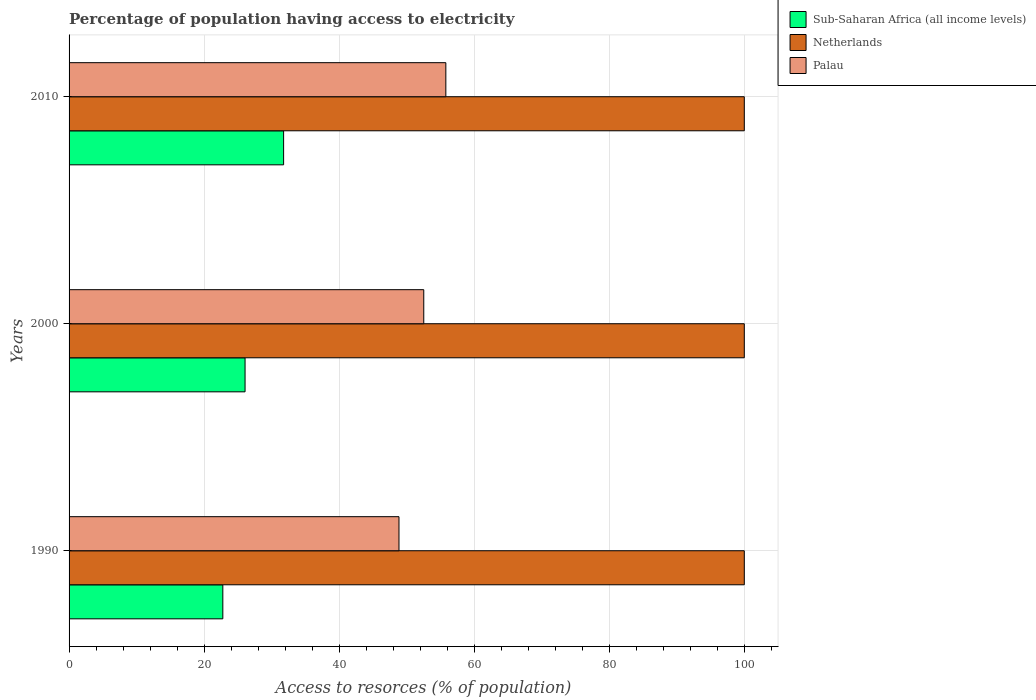How many different coloured bars are there?
Ensure brevity in your answer.  3. How many groups of bars are there?
Provide a short and direct response. 3. Are the number of bars per tick equal to the number of legend labels?
Offer a very short reply. Yes. In how many cases, is the number of bars for a given year not equal to the number of legend labels?
Your response must be concise. 0. What is the percentage of population having access to electricity in Palau in 2000?
Your answer should be compact. 52.53. Across all years, what is the maximum percentage of population having access to electricity in Sub-Saharan Africa (all income levels)?
Your response must be concise. 31.77. Across all years, what is the minimum percentage of population having access to electricity in Netherlands?
Your answer should be very brief. 100. In which year was the percentage of population having access to electricity in Netherlands minimum?
Keep it short and to the point. 1990. What is the total percentage of population having access to electricity in Netherlands in the graph?
Offer a terse response. 300. What is the difference between the percentage of population having access to electricity in Palau in 1990 and that in 2010?
Keep it short and to the point. -6.94. What is the difference between the percentage of population having access to electricity in Palau in 1990 and the percentage of population having access to electricity in Sub-Saharan Africa (all income levels) in 2000?
Ensure brevity in your answer.  22.79. What is the average percentage of population having access to electricity in Sub-Saharan Africa (all income levels) per year?
Offer a very short reply. 26.87. In the year 2000, what is the difference between the percentage of population having access to electricity in Palau and percentage of population having access to electricity in Sub-Saharan Africa (all income levels)?
Your response must be concise. 26.47. In how many years, is the percentage of population having access to electricity in Netherlands greater than 24 %?
Ensure brevity in your answer.  3. What is the ratio of the percentage of population having access to electricity in Sub-Saharan Africa (all income levels) in 1990 to that in 2000?
Provide a succinct answer. 0.87. What is the difference between the highest and the lowest percentage of population having access to electricity in Netherlands?
Keep it short and to the point. 0. In how many years, is the percentage of population having access to electricity in Sub-Saharan Africa (all income levels) greater than the average percentage of population having access to electricity in Sub-Saharan Africa (all income levels) taken over all years?
Offer a very short reply. 1. What does the 1st bar from the bottom in 2000 represents?
Offer a very short reply. Sub-Saharan Africa (all income levels). Are all the bars in the graph horizontal?
Keep it short and to the point. Yes. What is the difference between two consecutive major ticks on the X-axis?
Your response must be concise. 20. Does the graph contain any zero values?
Your answer should be very brief. No. How are the legend labels stacked?
Offer a very short reply. Vertical. What is the title of the graph?
Offer a very short reply. Percentage of population having access to electricity. Does "Jamaica" appear as one of the legend labels in the graph?
Ensure brevity in your answer.  No. What is the label or title of the X-axis?
Make the answer very short. Access to resorces (% of population). What is the Access to resorces (% of population) of Sub-Saharan Africa (all income levels) in 1990?
Keep it short and to the point. 22.77. What is the Access to resorces (% of population) in Netherlands in 1990?
Provide a succinct answer. 100. What is the Access to resorces (% of population) in Palau in 1990?
Your response must be concise. 48.86. What is the Access to resorces (% of population) of Sub-Saharan Africa (all income levels) in 2000?
Offer a terse response. 26.06. What is the Access to resorces (% of population) in Netherlands in 2000?
Offer a very short reply. 100. What is the Access to resorces (% of population) of Palau in 2000?
Give a very brief answer. 52.53. What is the Access to resorces (% of population) of Sub-Saharan Africa (all income levels) in 2010?
Ensure brevity in your answer.  31.77. What is the Access to resorces (% of population) in Palau in 2010?
Provide a succinct answer. 55.8. Across all years, what is the maximum Access to resorces (% of population) of Sub-Saharan Africa (all income levels)?
Keep it short and to the point. 31.77. Across all years, what is the maximum Access to resorces (% of population) of Netherlands?
Your response must be concise. 100. Across all years, what is the maximum Access to resorces (% of population) in Palau?
Your response must be concise. 55.8. Across all years, what is the minimum Access to resorces (% of population) in Sub-Saharan Africa (all income levels)?
Your answer should be compact. 22.77. Across all years, what is the minimum Access to resorces (% of population) of Netherlands?
Keep it short and to the point. 100. Across all years, what is the minimum Access to resorces (% of population) in Palau?
Your response must be concise. 48.86. What is the total Access to resorces (% of population) in Sub-Saharan Africa (all income levels) in the graph?
Your response must be concise. 80.61. What is the total Access to resorces (% of population) of Netherlands in the graph?
Keep it short and to the point. 300. What is the total Access to resorces (% of population) in Palau in the graph?
Your answer should be compact. 157.19. What is the difference between the Access to resorces (% of population) in Sub-Saharan Africa (all income levels) in 1990 and that in 2000?
Give a very brief answer. -3.29. What is the difference between the Access to resorces (% of population) in Netherlands in 1990 and that in 2000?
Give a very brief answer. 0. What is the difference between the Access to resorces (% of population) of Palau in 1990 and that in 2000?
Offer a very short reply. -3.67. What is the difference between the Access to resorces (% of population) in Sub-Saharan Africa (all income levels) in 1990 and that in 2010?
Ensure brevity in your answer.  -9. What is the difference between the Access to resorces (% of population) of Palau in 1990 and that in 2010?
Your answer should be very brief. -6.94. What is the difference between the Access to resorces (% of population) of Sub-Saharan Africa (all income levels) in 2000 and that in 2010?
Provide a short and direct response. -5.71. What is the difference between the Access to resorces (% of population) of Palau in 2000 and that in 2010?
Your answer should be very brief. -3.27. What is the difference between the Access to resorces (% of population) in Sub-Saharan Africa (all income levels) in 1990 and the Access to resorces (% of population) in Netherlands in 2000?
Make the answer very short. -77.23. What is the difference between the Access to resorces (% of population) in Sub-Saharan Africa (all income levels) in 1990 and the Access to resorces (% of population) in Palau in 2000?
Your answer should be very brief. -29.76. What is the difference between the Access to resorces (% of population) of Netherlands in 1990 and the Access to resorces (% of population) of Palau in 2000?
Give a very brief answer. 47.47. What is the difference between the Access to resorces (% of population) of Sub-Saharan Africa (all income levels) in 1990 and the Access to resorces (% of population) of Netherlands in 2010?
Offer a very short reply. -77.23. What is the difference between the Access to resorces (% of population) in Sub-Saharan Africa (all income levels) in 1990 and the Access to resorces (% of population) in Palau in 2010?
Offer a very short reply. -33.03. What is the difference between the Access to resorces (% of population) of Netherlands in 1990 and the Access to resorces (% of population) of Palau in 2010?
Your response must be concise. 44.2. What is the difference between the Access to resorces (% of population) in Sub-Saharan Africa (all income levels) in 2000 and the Access to resorces (% of population) in Netherlands in 2010?
Your answer should be compact. -73.94. What is the difference between the Access to resorces (% of population) of Sub-Saharan Africa (all income levels) in 2000 and the Access to resorces (% of population) of Palau in 2010?
Keep it short and to the point. -29.74. What is the difference between the Access to resorces (% of population) in Netherlands in 2000 and the Access to resorces (% of population) in Palau in 2010?
Your answer should be very brief. 44.2. What is the average Access to resorces (% of population) of Sub-Saharan Africa (all income levels) per year?
Your answer should be compact. 26.87. What is the average Access to resorces (% of population) of Palau per year?
Your response must be concise. 52.4. In the year 1990, what is the difference between the Access to resorces (% of population) of Sub-Saharan Africa (all income levels) and Access to resorces (% of population) of Netherlands?
Provide a succinct answer. -77.23. In the year 1990, what is the difference between the Access to resorces (% of population) of Sub-Saharan Africa (all income levels) and Access to resorces (% of population) of Palau?
Offer a terse response. -26.09. In the year 1990, what is the difference between the Access to resorces (% of population) in Netherlands and Access to resorces (% of population) in Palau?
Offer a terse response. 51.14. In the year 2000, what is the difference between the Access to resorces (% of population) of Sub-Saharan Africa (all income levels) and Access to resorces (% of population) of Netherlands?
Your response must be concise. -73.94. In the year 2000, what is the difference between the Access to resorces (% of population) of Sub-Saharan Africa (all income levels) and Access to resorces (% of population) of Palau?
Provide a short and direct response. -26.47. In the year 2000, what is the difference between the Access to resorces (% of population) of Netherlands and Access to resorces (% of population) of Palau?
Provide a succinct answer. 47.47. In the year 2010, what is the difference between the Access to resorces (% of population) of Sub-Saharan Africa (all income levels) and Access to resorces (% of population) of Netherlands?
Provide a succinct answer. -68.23. In the year 2010, what is the difference between the Access to resorces (% of population) in Sub-Saharan Africa (all income levels) and Access to resorces (% of population) in Palau?
Ensure brevity in your answer.  -24.03. In the year 2010, what is the difference between the Access to resorces (% of population) of Netherlands and Access to resorces (% of population) of Palau?
Offer a terse response. 44.2. What is the ratio of the Access to resorces (% of population) in Sub-Saharan Africa (all income levels) in 1990 to that in 2000?
Make the answer very short. 0.87. What is the ratio of the Access to resorces (% of population) in Netherlands in 1990 to that in 2000?
Your answer should be very brief. 1. What is the ratio of the Access to resorces (% of population) of Palau in 1990 to that in 2000?
Keep it short and to the point. 0.93. What is the ratio of the Access to resorces (% of population) of Sub-Saharan Africa (all income levels) in 1990 to that in 2010?
Offer a terse response. 0.72. What is the ratio of the Access to resorces (% of population) of Netherlands in 1990 to that in 2010?
Make the answer very short. 1. What is the ratio of the Access to resorces (% of population) in Palau in 1990 to that in 2010?
Provide a short and direct response. 0.88. What is the ratio of the Access to resorces (% of population) in Sub-Saharan Africa (all income levels) in 2000 to that in 2010?
Offer a very short reply. 0.82. What is the ratio of the Access to resorces (% of population) in Netherlands in 2000 to that in 2010?
Offer a very short reply. 1. What is the ratio of the Access to resorces (% of population) in Palau in 2000 to that in 2010?
Provide a succinct answer. 0.94. What is the difference between the highest and the second highest Access to resorces (% of population) in Sub-Saharan Africa (all income levels)?
Give a very brief answer. 5.71. What is the difference between the highest and the second highest Access to resorces (% of population) in Netherlands?
Give a very brief answer. 0. What is the difference between the highest and the second highest Access to resorces (% of population) of Palau?
Keep it short and to the point. 3.27. What is the difference between the highest and the lowest Access to resorces (% of population) of Sub-Saharan Africa (all income levels)?
Provide a succinct answer. 9. What is the difference between the highest and the lowest Access to resorces (% of population) in Palau?
Provide a succinct answer. 6.94. 